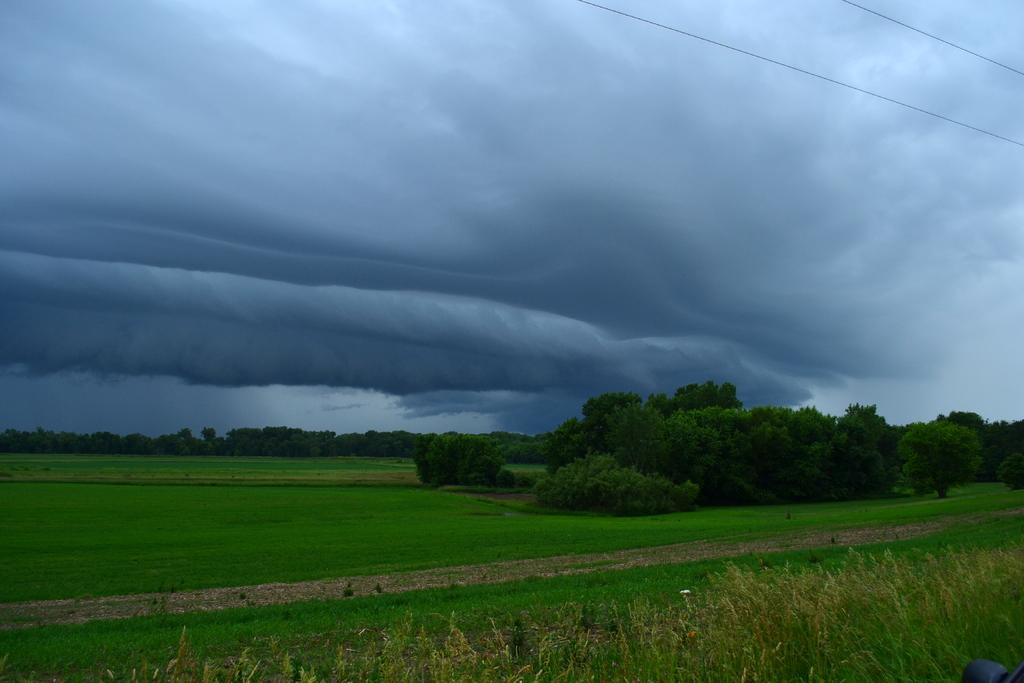What type of vegetation can be seen in the image? There are trees, grass, and plants in the image. What else is present in the image besides vegetation? Current wires are visible in the top right corner of the image. What can be seen in the background of the image? The sky is visible in the background of the image. How many times does the person in the image cough while walking with a basket? There is no person in the image, nor is there any mention of a cough or a basket. 